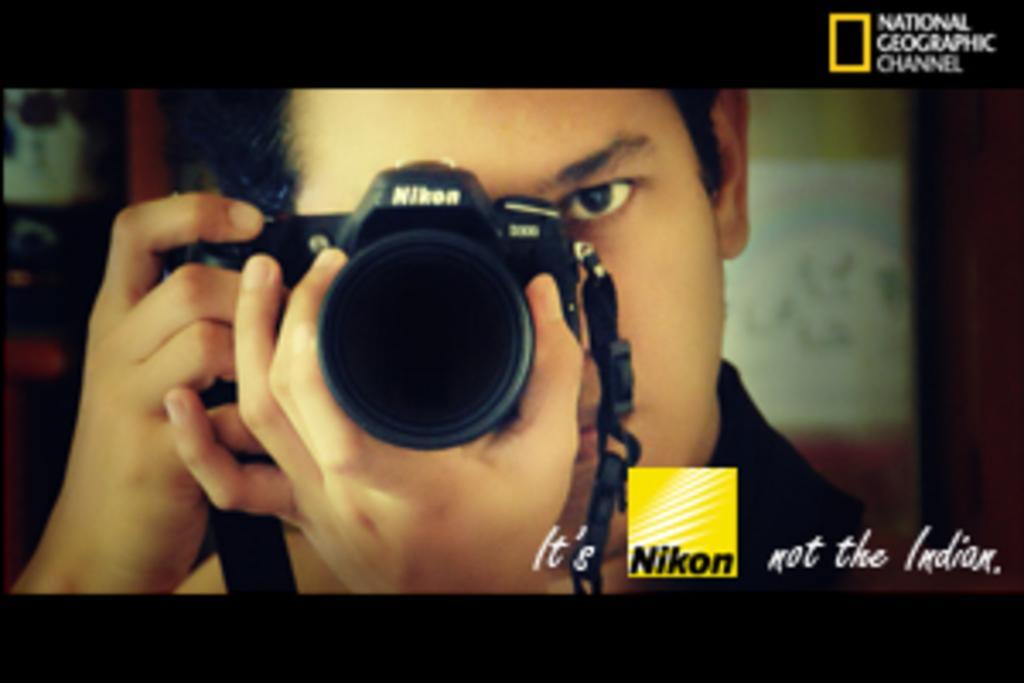Please provide a concise description of this image. In the picture we can see a national geographic channel image on it, we can see a man holding a camera and capturing something, the camera is black in color with a tag and written on the bottom as It's Nikon not Indian. 